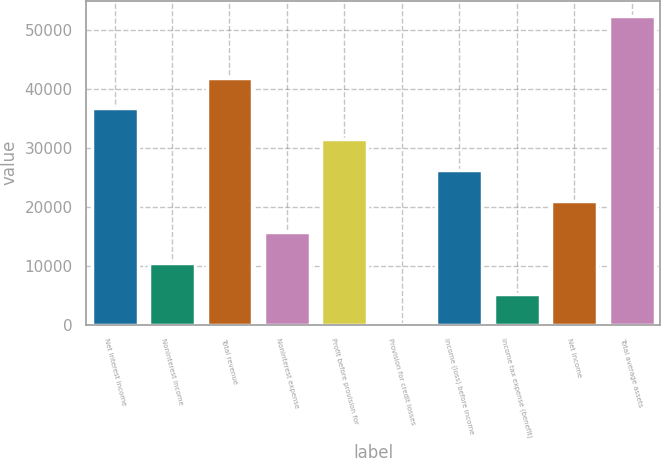<chart> <loc_0><loc_0><loc_500><loc_500><bar_chart><fcel>Net interest income<fcel>Noninterest income<fcel>Total revenue<fcel>Noninterest expense<fcel>Profit before provision for<fcel>Provision for credit losses<fcel>Income (loss) before income<fcel>Income tax expense (benefit)<fcel>Net income<fcel>Total average assets<nl><fcel>36661.2<fcel>10493.2<fcel>41894.8<fcel>15726.8<fcel>31427.6<fcel>26<fcel>26194<fcel>5259.6<fcel>20960.4<fcel>52362<nl></chart> 